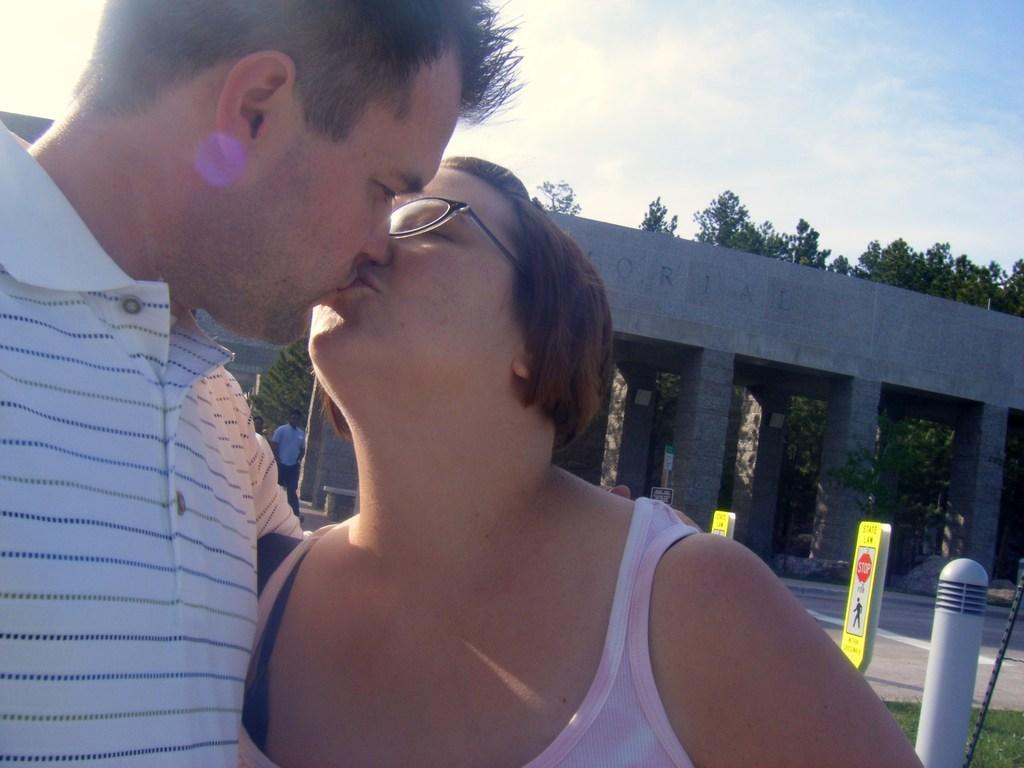Who are the people in the image? There is a man and a woman in the image. What are the man and woman doing in the image? The man and woman are kissing. What objects can be seen in the image besides the people? There are boards and pillars in the image. What can be seen in the background of the image? The sky is visible in the background of the image, and clouds are present. What type of crack is visible in the image? There is no crack present in the image. How many friends are visible in the image? The image only shows a man and a woman, so there are no friends visible. 